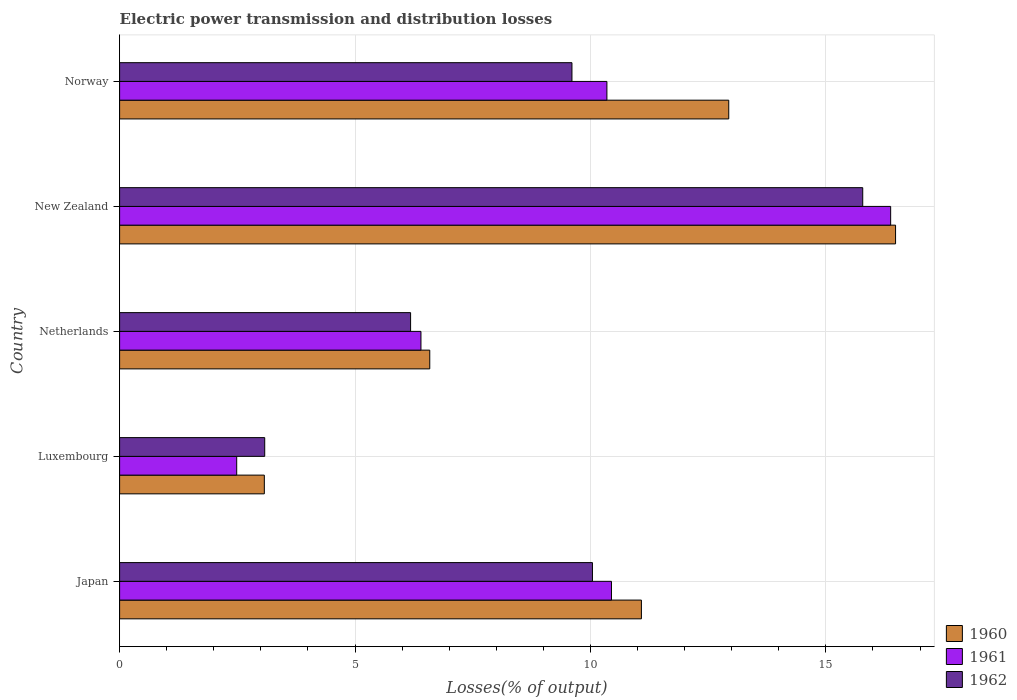Are the number of bars on each tick of the Y-axis equal?
Keep it short and to the point. Yes. How many bars are there on the 3rd tick from the top?
Provide a succinct answer. 3. How many bars are there on the 2nd tick from the bottom?
Keep it short and to the point. 3. What is the label of the 2nd group of bars from the top?
Give a very brief answer. New Zealand. What is the electric power transmission and distribution losses in 1962 in Norway?
Make the answer very short. 9.61. Across all countries, what is the maximum electric power transmission and distribution losses in 1962?
Ensure brevity in your answer.  15.78. Across all countries, what is the minimum electric power transmission and distribution losses in 1960?
Your answer should be very brief. 3.07. In which country was the electric power transmission and distribution losses in 1960 maximum?
Provide a short and direct response. New Zealand. In which country was the electric power transmission and distribution losses in 1960 minimum?
Keep it short and to the point. Luxembourg. What is the total electric power transmission and distribution losses in 1960 in the graph?
Your answer should be very brief. 50.16. What is the difference between the electric power transmission and distribution losses in 1960 in Netherlands and that in New Zealand?
Offer a terse response. -9.89. What is the difference between the electric power transmission and distribution losses in 1962 in New Zealand and the electric power transmission and distribution losses in 1960 in Japan?
Provide a short and direct response. 4.7. What is the average electric power transmission and distribution losses in 1962 per country?
Provide a succinct answer. 8.94. What is the difference between the electric power transmission and distribution losses in 1962 and electric power transmission and distribution losses in 1961 in Norway?
Your answer should be compact. -0.74. What is the ratio of the electric power transmission and distribution losses in 1960 in Luxembourg to that in Norway?
Make the answer very short. 0.24. Is the electric power transmission and distribution losses in 1960 in Netherlands less than that in New Zealand?
Your answer should be very brief. Yes. What is the difference between the highest and the second highest electric power transmission and distribution losses in 1960?
Your response must be concise. 3.54. What is the difference between the highest and the lowest electric power transmission and distribution losses in 1961?
Offer a terse response. 13.89. In how many countries, is the electric power transmission and distribution losses in 1960 greater than the average electric power transmission and distribution losses in 1960 taken over all countries?
Your response must be concise. 3. Is the sum of the electric power transmission and distribution losses in 1961 in Japan and Luxembourg greater than the maximum electric power transmission and distribution losses in 1960 across all countries?
Give a very brief answer. No. What does the 3rd bar from the top in Netherlands represents?
Give a very brief answer. 1960. What does the 1st bar from the bottom in Norway represents?
Provide a succinct answer. 1960. Are the values on the major ticks of X-axis written in scientific E-notation?
Provide a short and direct response. No. Does the graph contain any zero values?
Provide a succinct answer. No. What is the title of the graph?
Provide a succinct answer. Electric power transmission and distribution losses. What is the label or title of the X-axis?
Make the answer very short. Losses(% of output). What is the Losses(% of output) in 1960 in Japan?
Provide a succinct answer. 11.08. What is the Losses(% of output) of 1961 in Japan?
Keep it short and to the point. 10.45. What is the Losses(% of output) in 1962 in Japan?
Provide a succinct answer. 10.04. What is the Losses(% of output) in 1960 in Luxembourg?
Provide a short and direct response. 3.07. What is the Losses(% of output) of 1961 in Luxembourg?
Provide a short and direct response. 2.49. What is the Losses(% of output) in 1962 in Luxembourg?
Ensure brevity in your answer.  3.08. What is the Losses(% of output) in 1960 in Netherlands?
Give a very brief answer. 6.59. What is the Losses(% of output) of 1961 in Netherlands?
Make the answer very short. 6.4. What is the Losses(% of output) of 1962 in Netherlands?
Offer a very short reply. 6.18. What is the Losses(% of output) in 1960 in New Zealand?
Offer a very short reply. 16.48. What is the Losses(% of output) of 1961 in New Zealand?
Ensure brevity in your answer.  16.38. What is the Losses(% of output) of 1962 in New Zealand?
Provide a short and direct response. 15.78. What is the Losses(% of output) in 1960 in Norway?
Offer a very short reply. 12.94. What is the Losses(% of output) of 1961 in Norway?
Your response must be concise. 10.35. What is the Losses(% of output) in 1962 in Norway?
Provide a succinct answer. 9.61. Across all countries, what is the maximum Losses(% of output) of 1960?
Provide a succinct answer. 16.48. Across all countries, what is the maximum Losses(% of output) in 1961?
Your answer should be compact. 16.38. Across all countries, what is the maximum Losses(% of output) in 1962?
Provide a short and direct response. 15.78. Across all countries, what is the minimum Losses(% of output) of 1960?
Make the answer very short. 3.07. Across all countries, what is the minimum Losses(% of output) of 1961?
Keep it short and to the point. 2.49. Across all countries, what is the minimum Losses(% of output) in 1962?
Offer a very short reply. 3.08. What is the total Losses(% of output) of 1960 in the graph?
Offer a very short reply. 50.16. What is the total Losses(% of output) of 1961 in the graph?
Provide a short and direct response. 46.06. What is the total Losses(% of output) in 1962 in the graph?
Keep it short and to the point. 44.7. What is the difference between the Losses(% of output) in 1960 in Japan and that in Luxembourg?
Provide a short and direct response. 8.01. What is the difference between the Losses(% of output) of 1961 in Japan and that in Luxembourg?
Keep it short and to the point. 7.96. What is the difference between the Losses(% of output) of 1962 in Japan and that in Luxembourg?
Provide a succinct answer. 6.96. What is the difference between the Losses(% of output) in 1960 in Japan and that in Netherlands?
Provide a short and direct response. 4.49. What is the difference between the Losses(% of output) in 1961 in Japan and that in Netherlands?
Your answer should be very brief. 4.05. What is the difference between the Losses(% of output) in 1962 in Japan and that in Netherlands?
Offer a very short reply. 3.86. What is the difference between the Losses(% of output) in 1960 in Japan and that in New Zealand?
Ensure brevity in your answer.  -5.4. What is the difference between the Losses(% of output) in 1961 in Japan and that in New Zealand?
Make the answer very short. -5.93. What is the difference between the Losses(% of output) of 1962 in Japan and that in New Zealand?
Provide a short and direct response. -5.74. What is the difference between the Losses(% of output) of 1960 in Japan and that in Norway?
Ensure brevity in your answer.  -1.85. What is the difference between the Losses(% of output) in 1961 in Japan and that in Norway?
Offer a terse response. 0.1. What is the difference between the Losses(% of output) in 1962 in Japan and that in Norway?
Offer a terse response. 0.44. What is the difference between the Losses(% of output) in 1960 in Luxembourg and that in Netherlands?
Your answer should be compact. -3.51. What is the difference between the Losses(% of output) of 1961 in Luxembourg and that in Netherlands?
Your answer should be very brief. -3.91. What is the difference between the Losses(% of output) in 1962 in Luxembourg and that in Netherlands?
Provide a succinct answer. -3.1. What is the difference between the Losses(% of output) of 1960 in Luxembourg and that in New Zealand?
Your answer should be compact. -13.41. What is the difference between the Losses(% of output) in 1961 in Luxembourg and that in New Zealand?
Provide a succinct answer. -13.89. What is the difference between the Losses(% of output) in 1962 in Luxembourg and that in New Zealand?
Your answer should be compact. -12.7. What is the difference between the Losses(% of output) of 1960 in Luxembourg and that in Norway?
Offer a terse response. -9.86. What is the difference between the Losses(% of output) of 1961 in Luxembourg and that in Norway?
Your answer should be compact. -7.86. What is the difference between the Losses(% of output) of 1962 in Luxembourg and that in Norway?
Make the answer very short. -6.53. What is the difference between the Losses(% of output) of 1960 in Netherlands and that in New Zealand?
Your response must be concise. -9.89. What is the difference between the Losses(% of output) in 1961 in Netherlands and that in New Zealand?
Offer a very short reply. -9.98. What is the difference between the Losses(% of output) in 1962 in Netherlands and that in New Zealand?
Keep it short and to the point. -9.6. What is the difference between the Losses(% of output) in 1960 in Netherlands and that in Norway?
Your response must be concise. -6.35. What is the difference between the Losses(% of output) in 1961 in Netherlands and that in Norway?
Make the answer very short. -3.95. What is the difference between the Losses(% of output) of 1962 in Netherlands and that in Norway?
Make the answer very short. -3.43. What is the difference between the Losses(% of output) in 1960 in New Zealand and that in Norway?
Offer a very short reply. 3.54. What is the difference between the Losses(% of output) of 1961 in New Zealand and that in Norway?
Your answer should be compact. 6.03. What is the difference between the Losses(% of output) of 1962 in New Zealand and that in Norway?
Your answer should be compact. 6.18. What is the difference between the Losses(% of output) of 1960 in Japan and the Losses(% of output) of 1961 in Luxembourg?
Your response must be concise. 8.6. What is the difference between the Losses(% of output) in 1960 in Japan and the Losses(% of output) in 1962 in Luxembourg?
Ensure brevity in your answer.  8. What is the difference between the Losses(% of output) of 1961 in Japan and the Losses(% of output) of 1962 in Luxembourg?
Your answer should be very brief. 7.36. What is the difference between the Losses(% of output) in 1960 in Japan and the Losses(% of output) in 1961 in Netherlands?
Provide a short and direct response. 4.68. What is the difference between the Losses(% of output) of 1960 in Japan and the Losses(% of output) of 1962 in Netherlands?
Offer a terse response. 4.9. What is the difference between the Losses(% of output) of 1961 in Japan and the Losses(% of output) of 1962 in Netherlands?
Make the answer very short. 4.27. What is the difference between the Losses(% of output) of 1960 in Japan and the Losses(% of output) of 1961 in New Zealand?
Provide a succinct answer. -5.29. What is the difference between the Losses(% of output) in 1960 in Japan and the Losses(% of output) in 1962 in New Zealand?
Your response must be concise. -4.7. What is the difference between the Losses(% of output) in 1961 in Japan and the Losses(% of output) in 1962 in New Zealand?
Provide a succinct answer. -5.34. What is the difference between the Losses(% of output) of 1960 in Japan and the Losses(% of output) of 1961 in Norway?
Provide a short and direct response. 0.73. What is the difference between the Losses(% of output) of 1960 in Japan and the Losses(% of output) of 1962 in Norway?
Your answer should be compact. 1.47. What is the difference between the Losses(% of output) in 1961 in Japan and the Losses(% of output) in 1962 in Norway?
Keep it short and to the point. 0.84. What is the difference between the Losses(% of output) in 1960 in Luxembourg and the Losses(% of output) in 1961 in Netherlands?
Provide a short and direct response. -3.33. What is the difference between the Losses(% of output) in 1960 in Luxembourg and the Losses(% of output) in 1962 in Netherlands?
Your answer should be compact. -3.11. What is the difference between the Losses(% of output) of 1961 in Luxembourg and the Losses(% of output) of 1962 in Netherlands?
Your response must be concise. -3.69. What is the difference between the Losses(% of output) of 1960 in Luxembourg and the Losses(% of output) of 1961 in New Zealand?
Offer a very short reply. -13.3. What is the difference between the Losses(% of output) in 1960 in Luxembourg and the Losses(% of output) in 1962 in New Zealand?
Give a very brief answer. -12.71. What is the difference between the Losses(% of output) in 1961 in Luxembourg and the Losses(% of output) in 1962 in New Zealand?
Keep it short and to the point. -13.3. What is the difference between the Losses(% of output) in 1960 in Luxembourg and the Losses(% of output) in 1961 in Norway?
Your response must be concise. -7.28. What is the difference between the Losses(% of output) in 1960 in Luxembourg and the Losses(% of output) in 1962 in Norway?
Your answer should be very brief. -6.53. What is the difference between the Losses(% of output) in 1961 in Luxembourg and the Losses(% of output) in 1962 in Norway?
Offer a very short reply. -7.12. What is the difference between the Losses(% of output) in 1960 in Netherlands and the Losses(% of output) in 1961 in New Zealand?
Give a very brief answer. -9.79. What is the difference between the Losses(% of output) in 1960 in Netherlands and the Losses(% of output) in 1962 in New Zealand?
Ensure brevity in your answer.  -9.2. What is the difference between the Losses(% of output) in 1961 in Netherlands and the Losses(% of output) in 1962 in New Zealand?
Make the answer very short. -9.38. What is the difference between the Losses(% of output) of 1960 in Netherlands and the Losses(% of output) of 1961 in Norway?
Provide a succinct answer. -3.76. What is the difference between the Losses(% of output) in 1960 in Netherlands and the Losses(% of output) in 1962 in Norway?
Give a very brief answer. -3.02. What is the difference between the Losses(% of output) in 1961 in Netherlands and the Losses(% of output) in 1962 in Norway?
Make the answer very short. -3.21. What is the difference between the Losses(% of output) of 1960 in New Zealand and the Losses(% of output) of 1961 in Norway?
Provide a short and direct response. 6.13. What is the difference between the Losses(% of output) of 1960 in New Zealand and the Losses(% of output) of 1962 in Norway?
Provide a short and direct response. 6.87. What is the difference between the Losses(% of output) in 1961 in New Zealand and the Losses(% of output) in 1962 in Norway?
Your response must be concise. 6.77. What is the average Losses(% of output) in 1960 per country?
Your response must be concise. 10.03. What is the average Losses(% of output) of 1961 per country?
Ensure brevity in your answer.  9.21. What is the average Losses(% of output) of 1962 per country?
Offer a terse response. 8.94. What is the difference between the Losses(% of output) of 1960 and Losses(% of output) of 1961 in Japan?
Ensure brevity in your answer.  0.64. What is the difference between the Losses(% of output) of 1960 and Losses(% of output) of 1962 in Japan?
Keep it short and to the point. 1.04. What is the difference between the Losses(% of output) of 1961 and Losses(% of output) of 1962 in Japan?
Ensure brevity in your answer.  0.4. What is the difference between the Losses(% of output) in 1960 and Losses(% of output) in 1961 in Luxembourg?
Your response must be concise. 0.59. What is the difference between the Losses(% of output) of 1960 and Losses(% of output) of 1962 in Luxembourg?
Offer a very short reply. -0.01. What is the difference between the Losses(% of output) in 1961 and Losses(% of output) in 1962 in Luxembourg?
Your answer should be compact. -0.6. What is the difference between the Losses(% of output) in 1960 and Losses(% of output) in 1961 in Netherlands?
Offer a terse response. 0.19. What is the difference between the Losses(% of output) in 1960 and Losses(% of output) in 1962 in Netherlands?
Your response must be concise. 0.41. What is the difference between the Losses(% of output) of 1961 and Losses(% of output) of 1962 in Netherlands?
Your answer should be compact. 0.22. What is the difference between the Losses(% of output) of 1960 and Losses(% of output) of 1961 in New Zealand?
Your answer should be very brief. 0.1. What is the difference between the Losses(% of output) in 1960 and Losses(% of output) in 1962 in New Zealand?
Your response must be concise. 0.7. What is the difference between the Losses(% of output) in 1961 and Losses(% of output) in 1962 in New Zealand?
Your answer should be compact. 0.59. What is the difference between the Losses(% of output) in 1960 and Losses(% of output) in 1961 in Norway?
Ensure brevity in your answer.  2.59. What is the difference between the Losses(% of output) of 1960 and Losses(% of output) of 1962 in Norway?
Make the answer very short. 3.33. What is the difference between the Losses(% of output) in 1961 and Losses(% of output) in 1962 in Norway?
Make the answer very short. 0.74. What is the ratio of the Losses(% of output) of 1960 in Japan to that in Luxembourg?
Offer a very short reply. 3.61. What is the ratio of the Losses(% of output) in 1961 in Japan to that in Luxembourg?
Ensure brevity in your answer.  4.2. What is the ratio of the Losses(% of output) of 1962 in Japan to that in Luxembourg?
Ensure brevity in your answer.  3.26. What is the ratio of the Losses(% of output) in 1960 in Japan to that in Netherlands?
Provide a short and direct response. 1.68. What is the ratio of the Losses(% of output) in 1961 in Japan to that in Netherlands?
Offer a terse response. 1.63. What is the ratio of the Losses(% of output) in 1962 in Japan to that in Netherlands?
Give a very brief answer. 1.62. What is the ratio of the Losses(% of output) of 1960 in Japan to that in New Zealand?
Make the answer very short. 0.67. What is the ratio of the Losses(% of output) in 1961 in Japan to that in New Zealand?
Give a very brief answer. 0.64. What is the ratio of the Losses(% of output) in 1962 in Japan to that in New Zealand?
Offer a very short reply. 0.64. What is the ratio of the Losses(% of output) of 1960 in Japan to that in Norway?
Ensure brevity in your answer.  0.86. What is the ratio of the Losses(% of output) of 1961 in Japan to that in Norway?
Offer a very short reply. 1.01. What is the ratio of the Losses(% of output) of 1962 in Japan to that in Norway?
Provide a succinct answer. 1.05. What is the ratio of the Losses(% of output) in 1960 in Luxembourg to that in Netherlands?
Your answer should be very brief. 0.47. What is the ratio of the Losses(% of output) in 1961 in Luxembourg to that in Netherlands?
Provide a succinct answer. 0.39. What is the ratio of the Losses(% of output) in 1962 in Luxembourg to that in Netherlands?
Provide a succinct answer. 0.5. What is the ratio of the Losses(% of output) in 1960 in Luxembourg to that in New Zealand?
Offer a very short reply. 0.19. What is the ratio of the Losses(% of output) of 1961 in Luxembourg to that in New Zealand?
Offer a terse response. 0.15. What is the ratio of the Losses(% of output) in 1962 in Luxembourg to that in New Zealand?
Give a very brief answer. 0.2. What is the ratio of the Losses(% of output) in 1960 in Luxembourg to that in Norway?
Provide a succinct answer. 0.24. What is the ratio of the Losses(% of output) in 1961 in Luxembourg to that in Norway?
Your answer should be compact. 0.24. What is the ratio of the Losses(% of output) of 1962 in Luxembourg to that in Norway?
Provide a short and direct response. 0.32. What is the ratio of the Losses(% of output) in 1960 in Netherlands to that in New Zealand?
Give a very brief answer. 0.4. What is the ratio of the Losses(% of output) in 1961 in Netherlands to that in New Zealand?
Provide a short and direct response. 0.39. What is the ratio of the Losses(% of output) of 1962 in Netherlands to that in New Zealand?
Keep it short and to the point. 0.39. What is the ratio of the Losses(% of output) of 1960 in Netherlands to that in Norway?
Provide a short and direct response. 0.51. What is the ratio of the Losses(% of output) in 1961 in Netherlands to that in Norway?
Offer a very short reply. 0.62. What is the ratio of the Losses(% of output) of 1962 in Netherlands to that in Norway?
Keep it short and to the point. 0.64. What is the ratio of the Losses(% of output) of 1960 in New Zealand to that in Norway?
Provide a short and direct response. 1.27. What is the ratio of the Losses(% of output) of 1961 in New Zealand to that in Norway?
Offer a very short reply. 1.58. What is the ratio of the Losses(% of output) in 1962 in New Zealand to that in Norway?
Your answer should be very brief. 1.64. What is the difference between the highest and the second highest Losses(% of output) of 1960?
Provide a succinct answer. 3.54. What is the difference between the highest and the second highest Losses(% of output) in 1961?
Offer a terse response. 5.93. What is the difference between the highest and the second highest Losses(% of output) in 1962?
Your answer should be very brief. 5.74. What is the difference between the highest and the lowest Losses(% of output) in 1960?
Offer a very short reply. 13.41. What is the difference between the highest and the lowest Losses(% of output) of 1961?
Provide a succinct answer. 13.89. What is the difference between the highest and the lowest Losses(% of output) in 1962?
Provide a short and direct response. 12.7. 